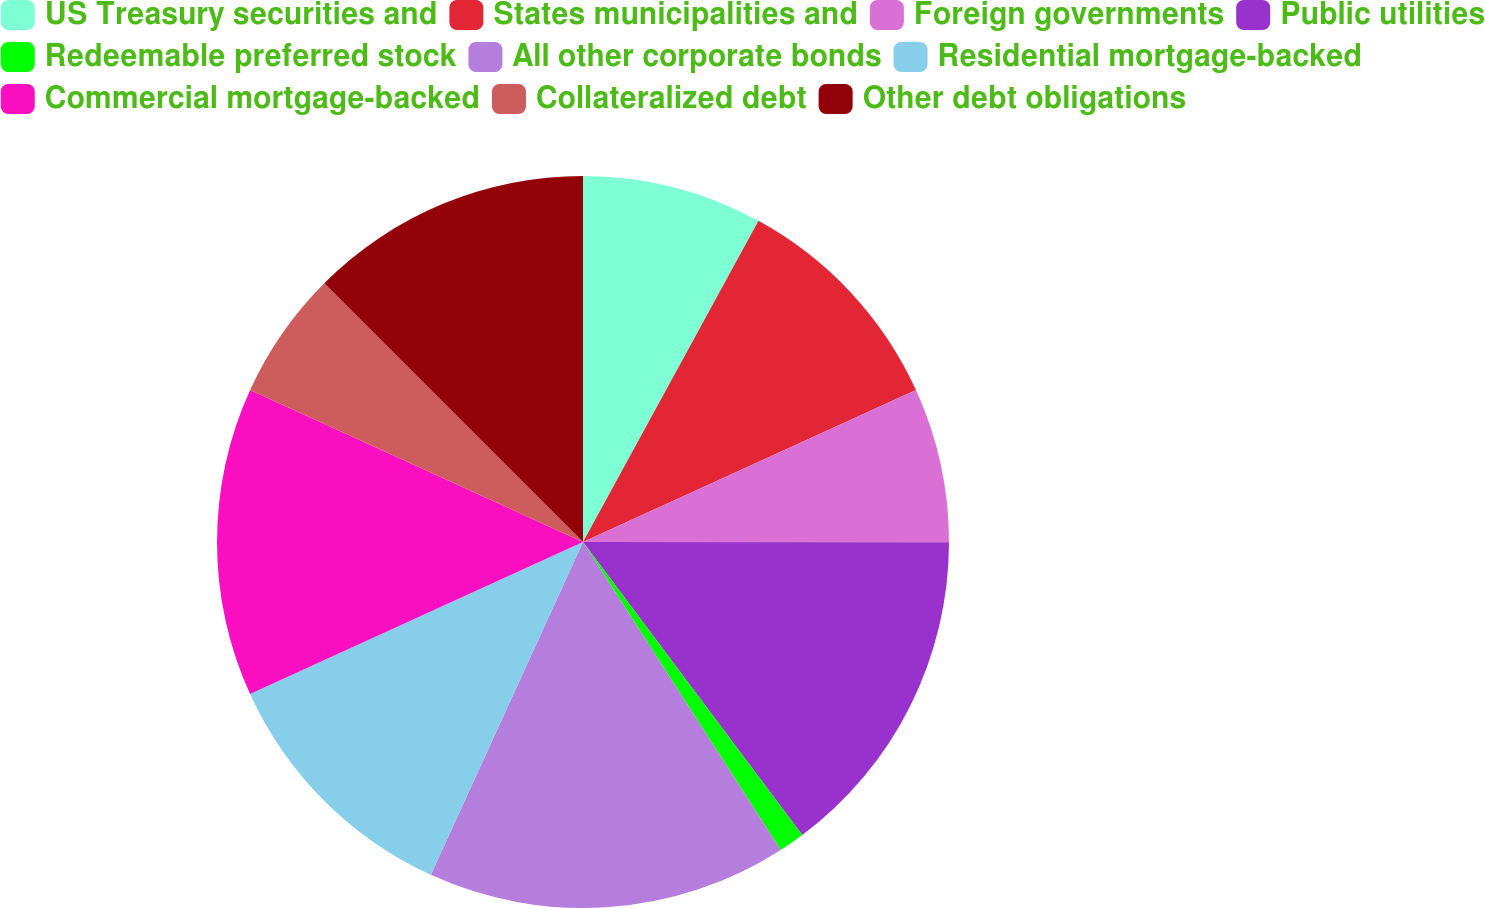Convert chart to OTSL. <chart><loc_0><loc_0><loc_500><loc_500><pie_chart><fcel>US Treasury securities and<fcel>States municipalities and<fcel>Foreign governments<fcel>Public utilities<fcel>Redeemable preferred stock<fcel>All other corporate bonds<fcel>Residential mortgage-backed<fcel>Commercial mortgage-backed<fcel>Collateralized debt<fcel>Other debt obligations<nl><fcel>7.96%<fcel>10.23%<fcel>6.82%<fcel>14.77%<fcel>1.14%<fcel>15.91%<fcel>11.36%<fcel>13.64%<fcel>5.68%<fcel>12.5%<nl></chart> 